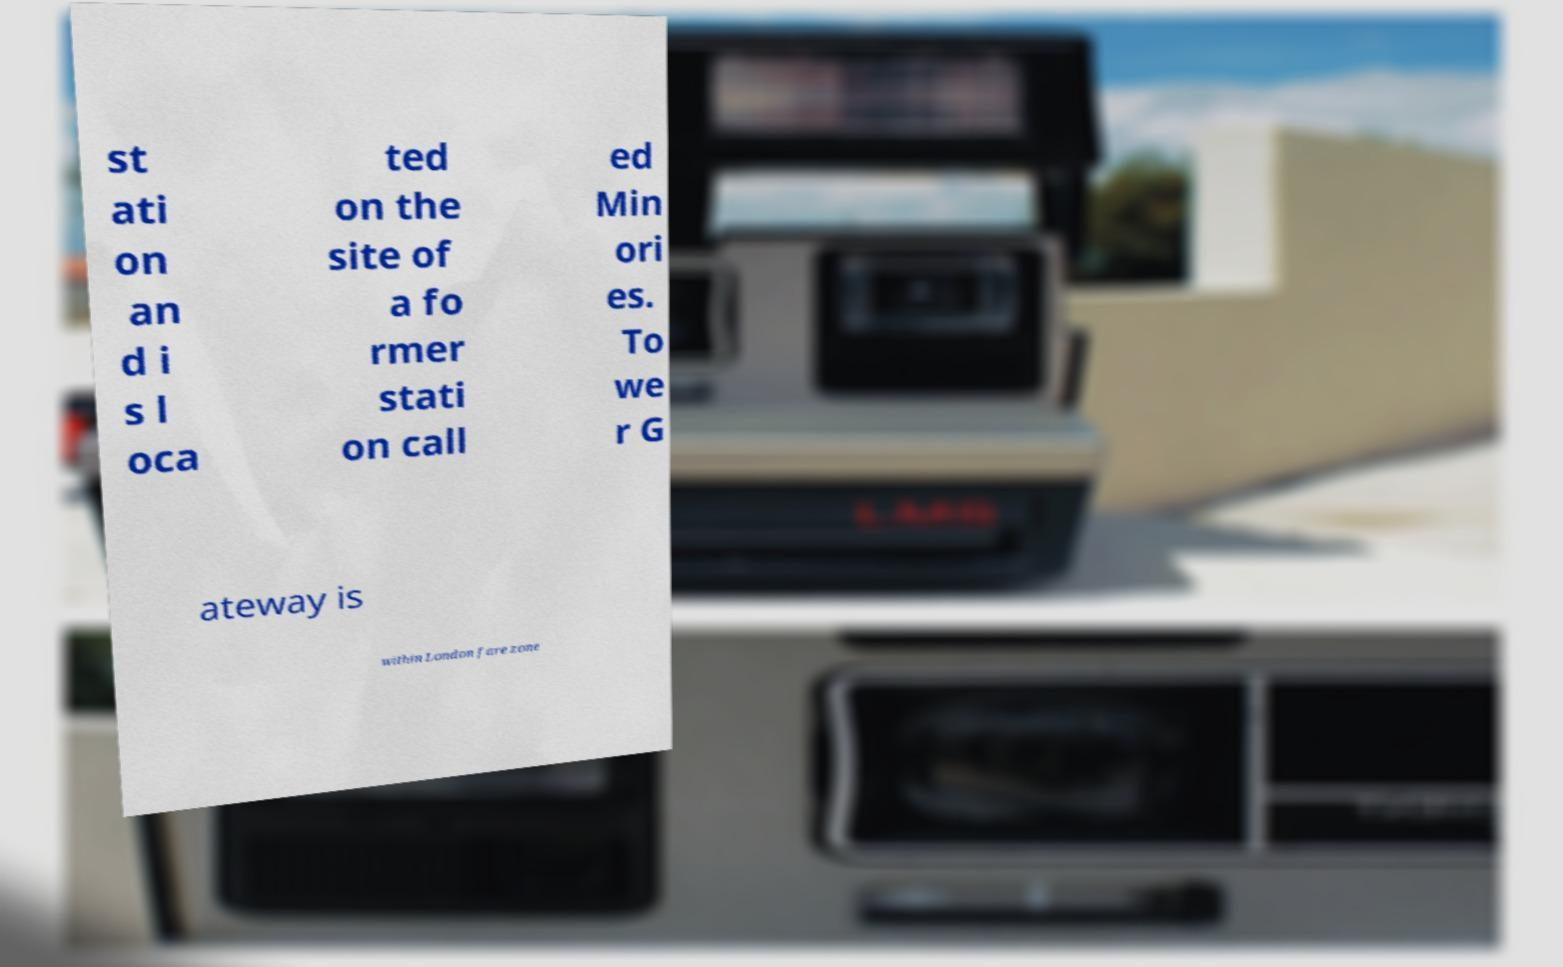For documentation purposes, I need the text within this image transcribed. Could you provide that? st ati on an d i s l oca ted on the site of a fo rmer stati on call ed Min ori es. To we r G ateway is within London fare zone 